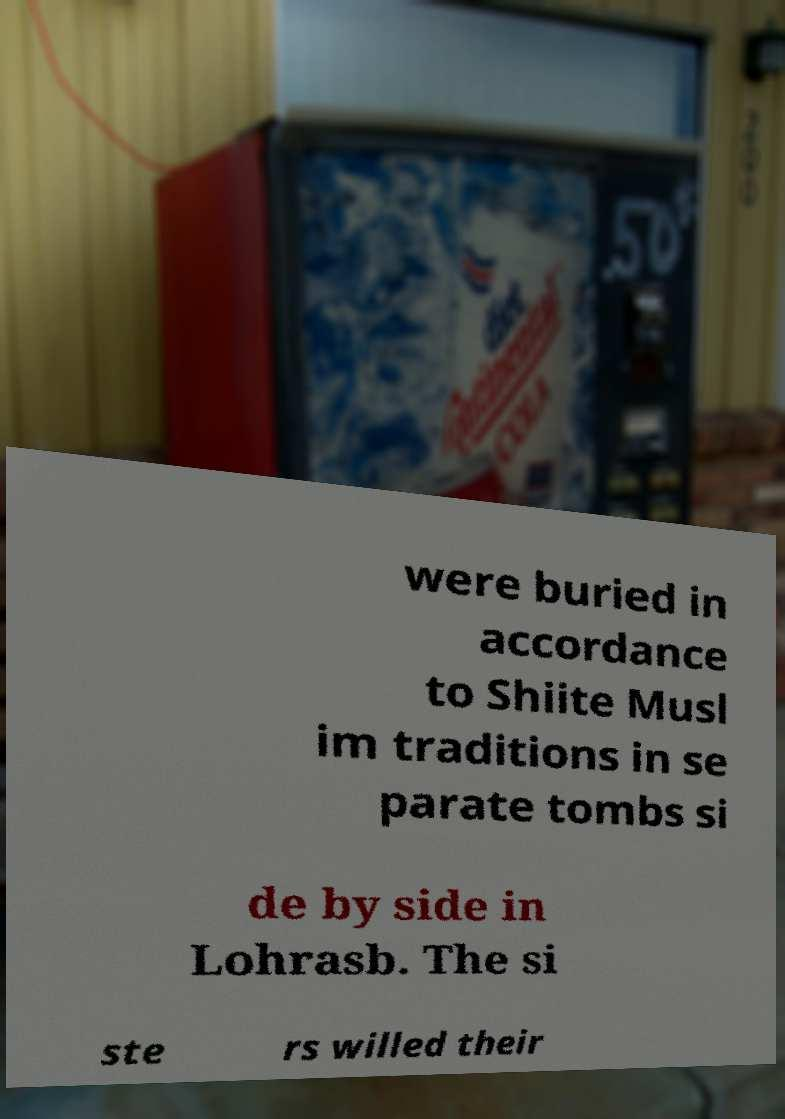Please read and relay the text visible in this image. What does it say? were buried in accordance to Shiite Musl im traditions in se parate tombs si de by side in Lohrasb. The si ste rs willed their 